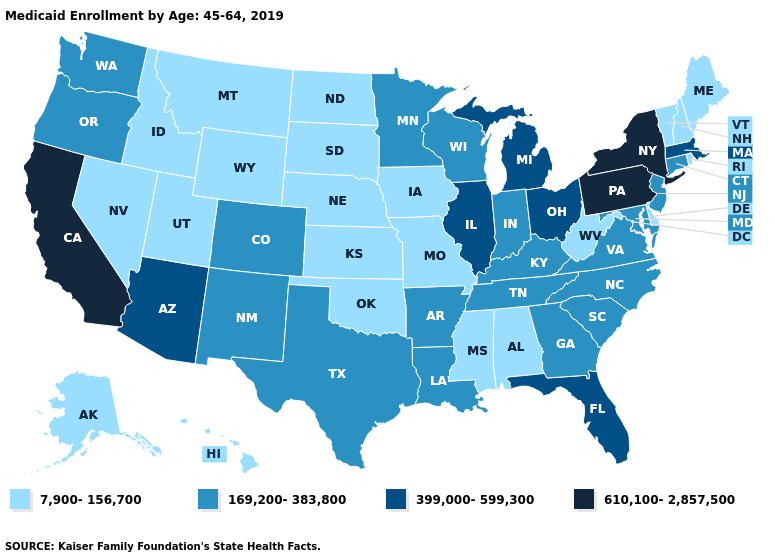What is the value of Delaware?
Write a very short answer. 7,900-156,700. Is the legend a continuous bar?
Be succinct. No. Does the first symbol in the legend represent the smallest category?
Concise answer only. Yes. How many symbols are there in the legend?
Short answer required. 4. Among the states that border Oregon , does Nevada have the highest value?
Be succinct. No. Among the states that border Oregon , does Idaho have the highest value?
Be succinct. No. What is the value of Louisiana?
Be succinct. 169,200-383,800. What is the lowest value in the USA?
Concise answer only. 7,900-156,700. What is the value of South Dakota?
Answer briefly. 7,900-156,700. What is the lowest value in the Northeast?
Write a very short answer. 7,900-156,700. What is the value of Colorado?
Quick response, please. 169,200-383,800. What is the value of Vermont?
Answer briefly. 7,900-156,700. Does Vermont have the lowest value in the Northeast?
Be succinct. Yes. What is the lowest value in the Northeast?
Quick response, please. 7,900-156,700. What is the highest value in states that border Delaware?
Be succinct. 610,100-2,857,500. 